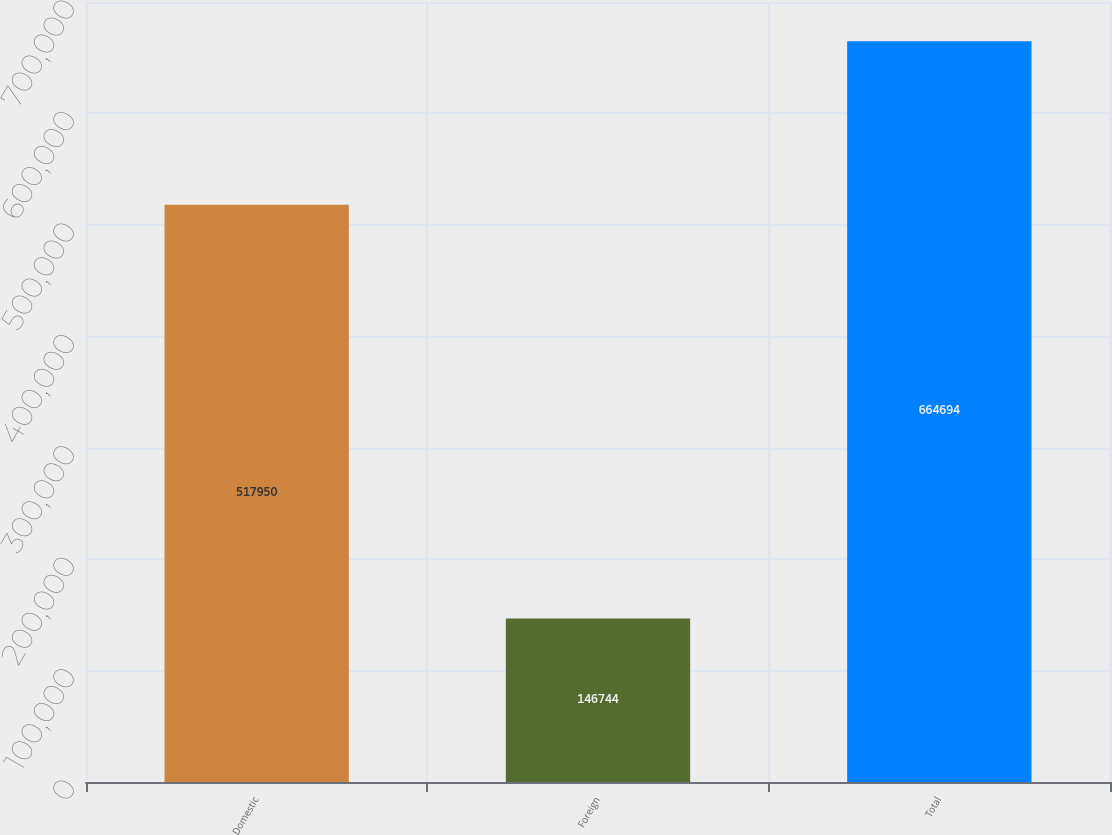Convert chart to OTSL. <chart><loc_0><loc_0><loc_500><loc_500><bar_chart><fcel>Domestic<fcel>Foreign<fcel>Total<nl><fcel>517950<fcel>146744<fcel>664694<nl></chart> 